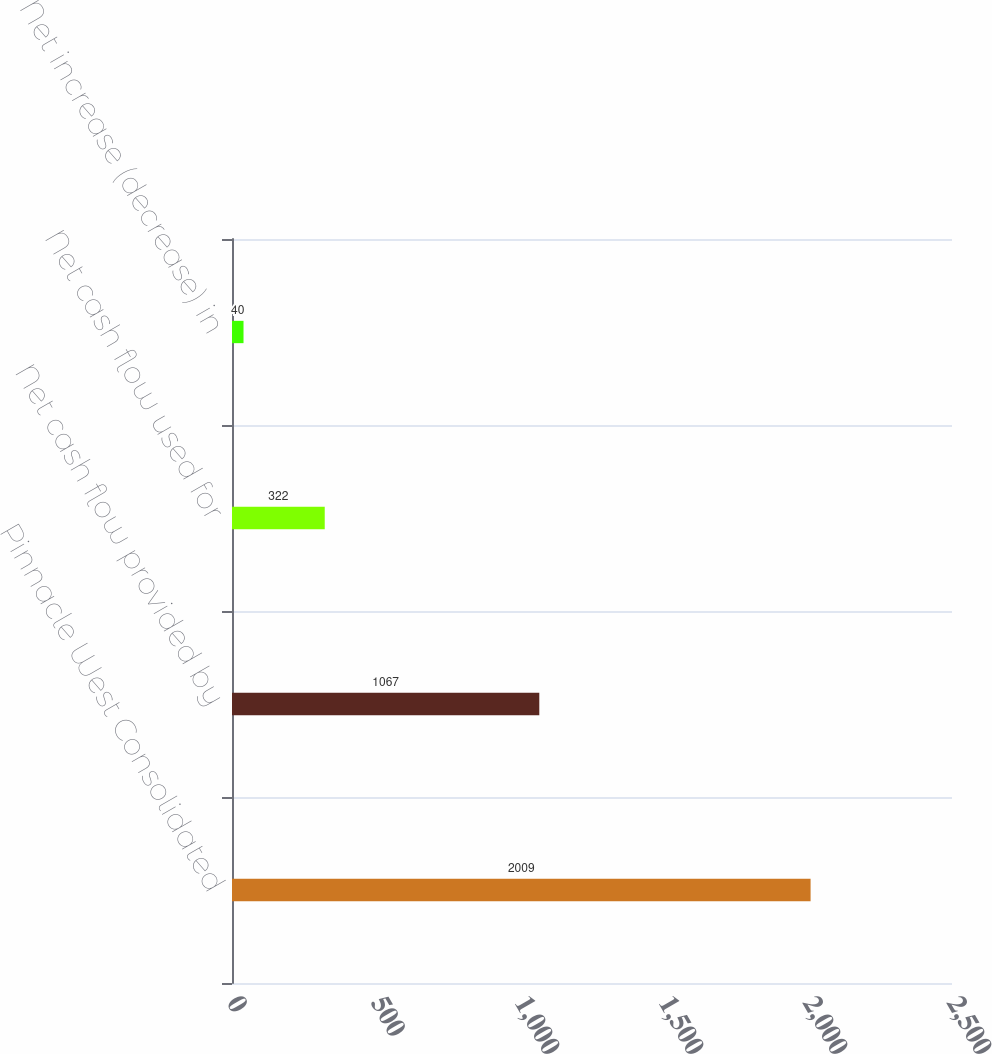Convert chart to OTSL. <chart><loc_0><loc_0><loc_500><loc_500><bar_chart><fcel>Pinnacle West Consolidated<fcel>Net cash flow provided by<fcel>Net cash flow used for<fcel>Net increase (decrease) in<nl><fcel>2009<fcel>1067<fcel>322<fcel>40<nl></chart> 